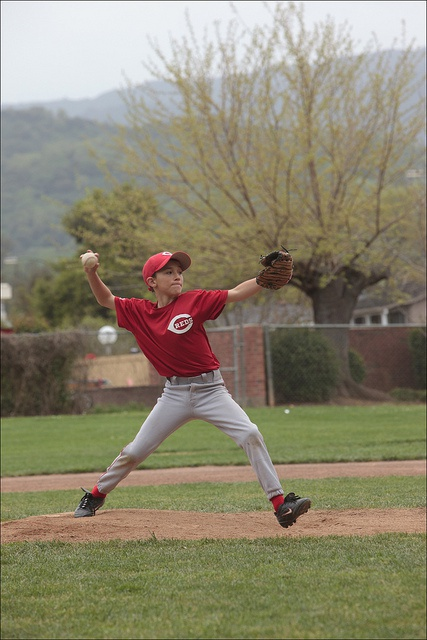Describe the objects in this image and their specific colors. I can see people in black, maroon, darkgray, gray, and brown tones, baseball glove in black, maroon, and gray tones, and sports ball in black, gray, tan, and lightgray tones in this image. 